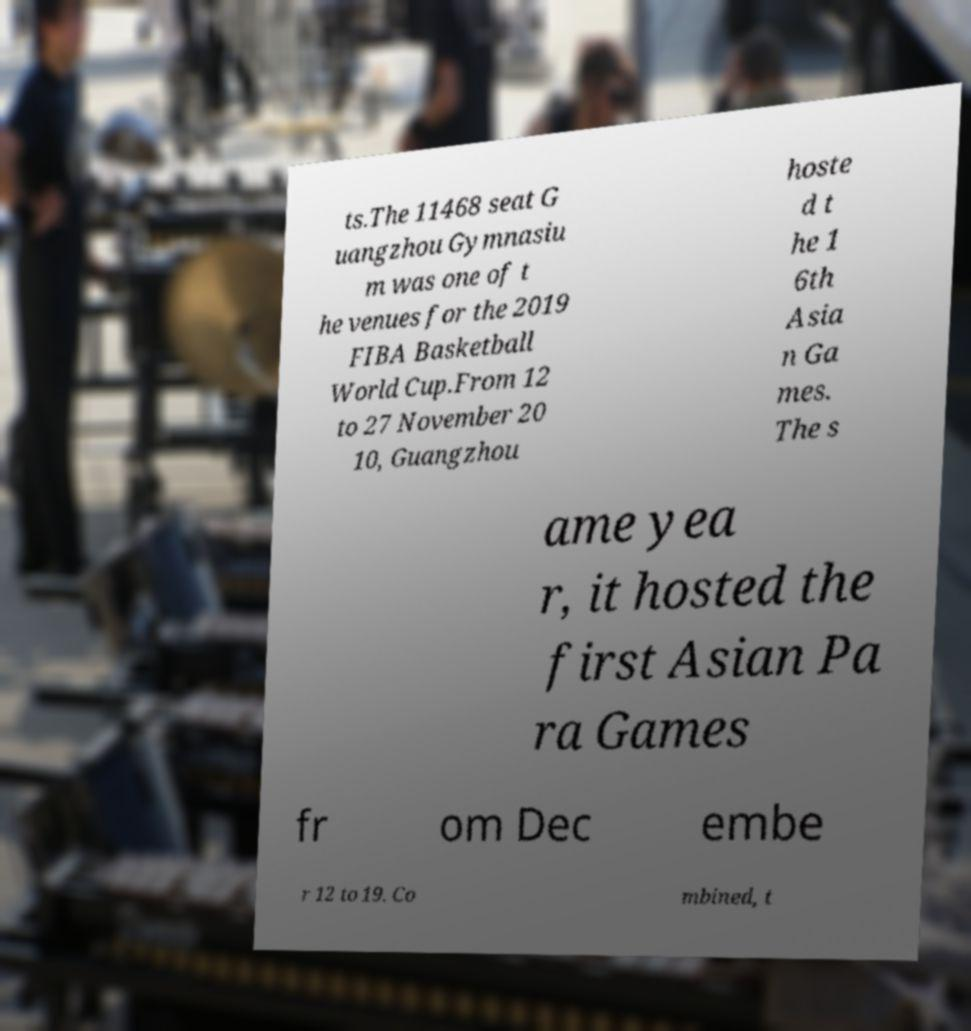Could you assist in decoding the text presented in this image and type it out clearly? ts.The 11468 seat G uangzhou Gymnasiu m was one of t he venues for the 2019 FIBA Basketball World Cup.From 12 to 27 November 20 10, Guangzhou hoste d t he 1 6th Asia n Ga mes. The s ame yea r, it hosted the first Asian Pa ra Games fr om Dec embe r 12 to 19. Co mbined, t 